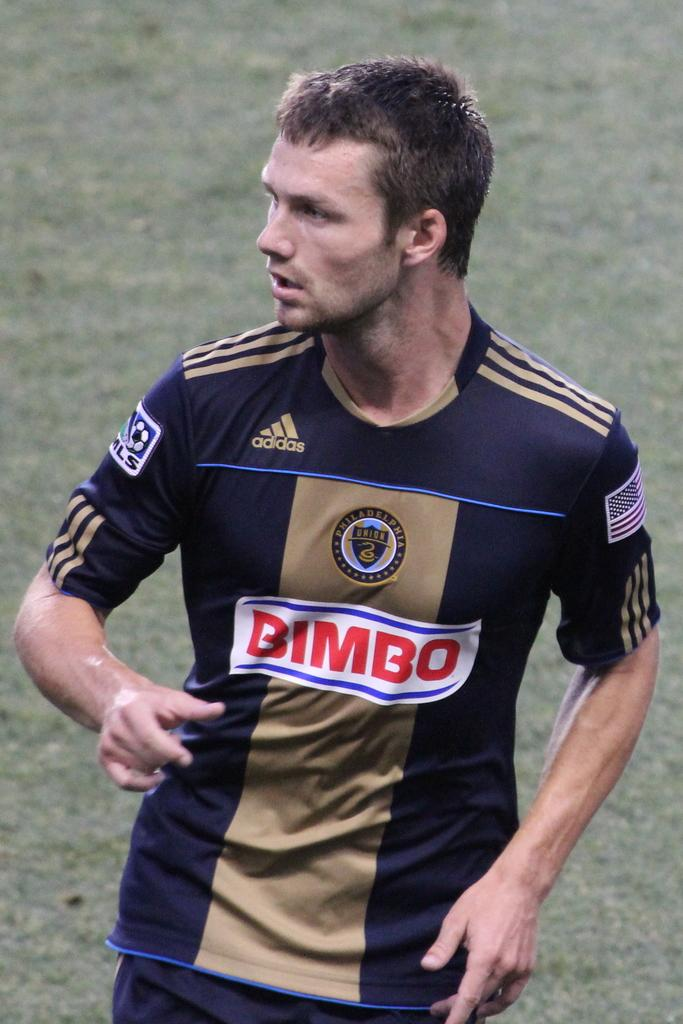<image>
Describe the image concisely. A man is wearing a jersey with the adidas logo on it. 